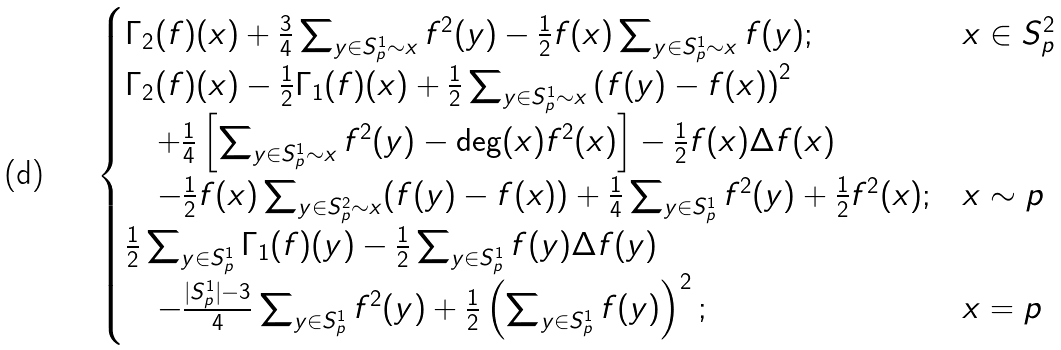<formula> <loc_0><loc_0><loc_500><loc_500>\begin{cases} \Gamma _ { 2 } ( f ) ( x ) + \frac { 3 } { 4 } \sum _ { y \in S ^ { 1 } _ { p } \sim x } f ^ { 2 } ( y ) - \frac { 1 } { 2 } f ( x ) \sum _ { y \in S ^ { 1 } _ { p } \sim x } f ( y ) ; & x \in S _ { p } ^ { 2 } \\ \Gamma _ { 2 } ( f ) ( x ) - \frac { 1 } { 2 } \Gamma _ { 1 } ( f ) ( x ) + \frac { 1 } { 2 } \sum _ { y \in S ^ { 1 } _ { p } \sim x } \left ( f ( y ) - f ( x ) \right ) ^ { 2 } \\ \quad + \frac { 1 } { 4 } \left [ \sum _ { y \in S ^ { 1 } _ { p } \sim x } f ^ { 2 } ( y ) - \deg ( x ) f ^ { 2 } ( x ) \right ] - \frac { 1 } { 2 } f ( x ) \Delta f ( x ) \\ \quad - \frac { 1 } { 2 } f ( x ) \sum _ { y \in S ^ { 2 } _ { p } \sim x } ( f ( y ) - f ( x ) ) + \frac { 1 } { 4 } \sum _ { y \in S ^ { 1 } _ { p } } f ^ { 2 } ( y ) + \frac { 1 } { 2 } f ^ { 2 } ( x ) ; & x \sim p \\ \frac { 1 } { 2 } \sum _ { y \in S ^ { 1 } _ { p } } \Gamma _ { 1 } ( f ) ( y ) - \frac { 1 } { 2 } \sum _ { y \in S ^ { 1 } _ { p } } f ( y ) \Delta f ( y ) \\ \quad - \frac { | S ^ { 1 } _ { p } | - 3 } { 4 } \sum _ { y \in S ^ { 1 } _ { p } } f ^ { 2 } ( y ) + \frac { 1 } { 2 } \left ( \sum _ { y \in S ^ { 1 } _ { p } } f ( y ) \right ) ^ { 2 } ; & x = p \end{cases}</formula> 